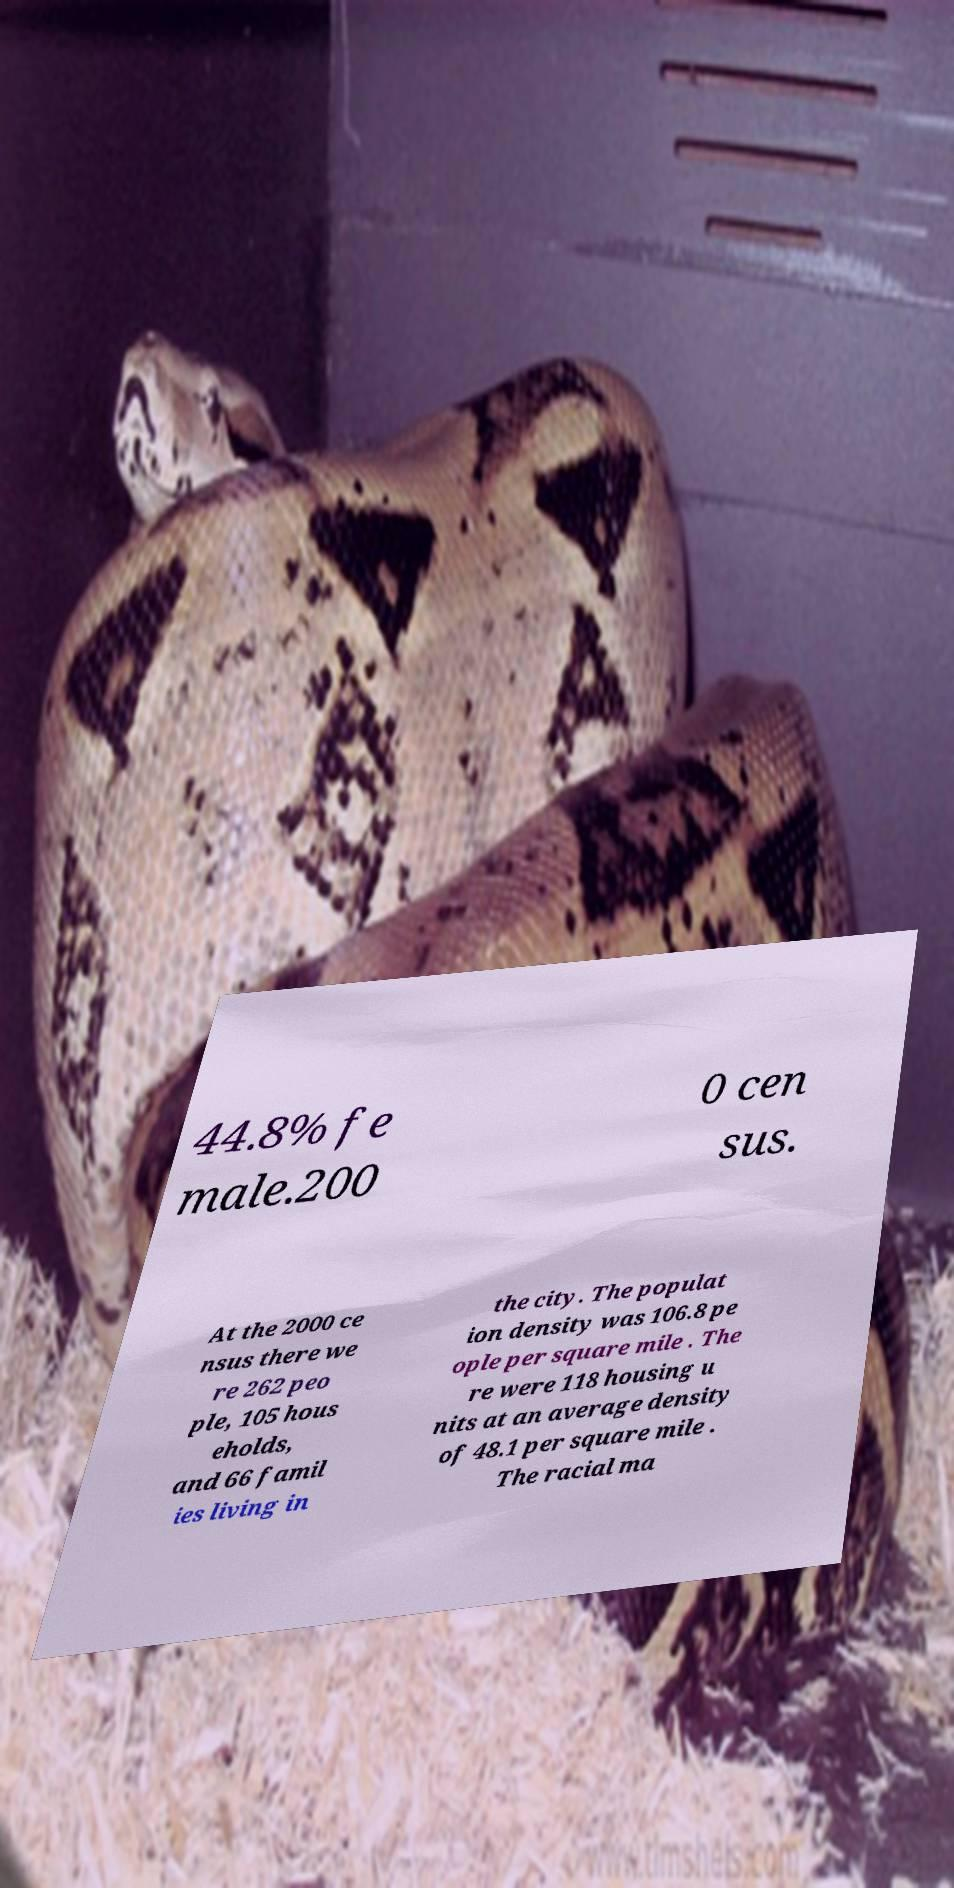Please read and relay the text visible in this image. What does it say? 44.8% fe male.200 0 cen sus. At the 2000 ce nsus there we re 262 peo ple, 105 hous eholds, and 66 famil ies living in the city. The populat ion density was 106.8 pe ople per square mile . The re were 118 housing u nits at an average density of 48.1 per square mile . The racial ma 